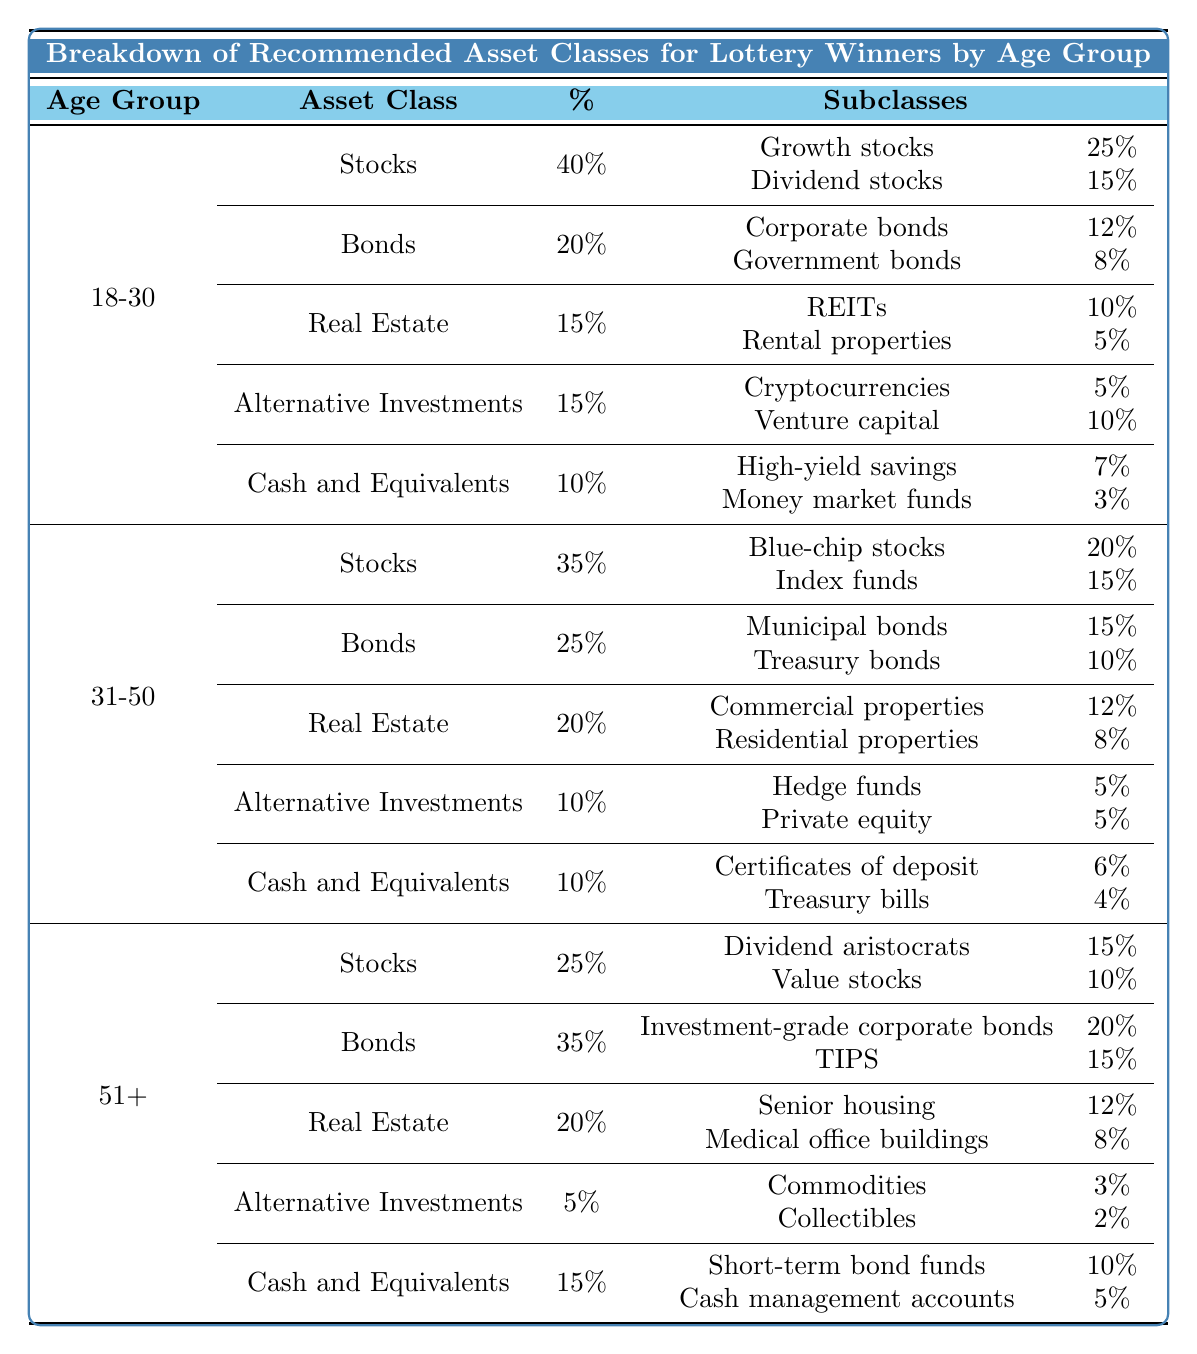What percentage of the 18-30 age group is recommended for Stocks? According to the table, Stocks constitute 40% of the recommended asset allocation for the 18-30 age group.
Answer: 40% Which subclass of Bonds has a higher percentage in the 31-50 age group: Municipal bonds or Treasury bonds? In the 31-50 age group, Municipal bonds represent 15%, while Treasury bonds represent 10%. Therefore, Municipal bonds have a higher percentage.
Answer: Municipal bonds What is the total percentage allocated to Real Estate for the age group 51 and older? For the 51+ age group, Real Estate has a total percentage of 20%.
Answer: 20% Is there a subclass of Cash and Equivalents in the 18-30 age group that has a percentage equal to or greater than 5%? Yes, in the 18-30 age group, High-yield savings has 7%, and Money market funds have 3%. Since 7% is greater than 5%, the statement is true.
Answer: Yes What is the difference in percentage allocation between the total Bonds for the 31-50 age group and the total Real Estate for the same group? Bonds total 25% and Real Estate totals 20% for the 31-50 age group. The difference is 25% - 20% = 5%.
Answer: 5% What is the sum of the percentages of Alternative Investments across all age groups? The percentages are 15% (18-30) + 10% (31-50) + 5% (51+) = 30%.
Answer: 30% Which age group has the highest percentage allocated to Cash and Equivalents? In the 51+ age group, Cash and Equivalents constitute 15%, while the other age groups have 10%. Therefore, the 51+ age group has the highest allocation.
Answer: 51+ Is it true that Growth stocks have a higher recommended percentage than Corporate bonds for the 18-30 age group? Growth stocks are allocated 25% while Corporate bonds are allocated 12%. Since 25% is greater than 12%, the statement is true.
Answer: Yes What is the average percentage allocated to stocks across all three age groups? Stocks are allocated 40% (18-30), 35% (31-50), and 25% (51+). The average is (40 + 35 + 25) / 3 = 33.33%.
Answer: 33.33% Which subclass of Real Estate in the 31-50 age group has the lowest recommended percentage? In the 31-50 age group, Residential properties represent 8% while Commercial properties represent 12%. Thus, Residential properties have the lowest percentage.
Answer: Residential properties 